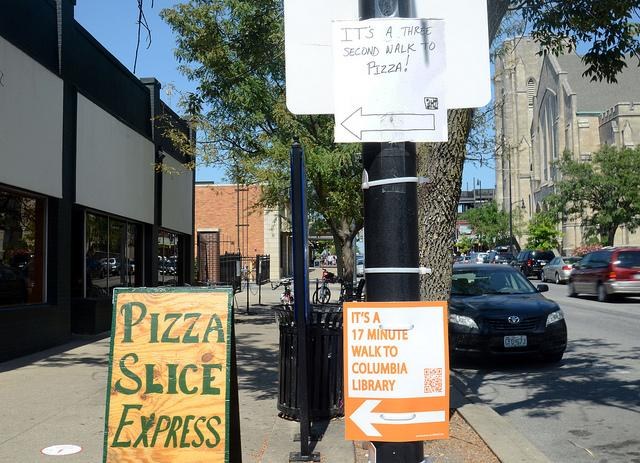What is the building across the street from the orange sign used for? Please explain your reasoning. religious services. The building is for religion. 